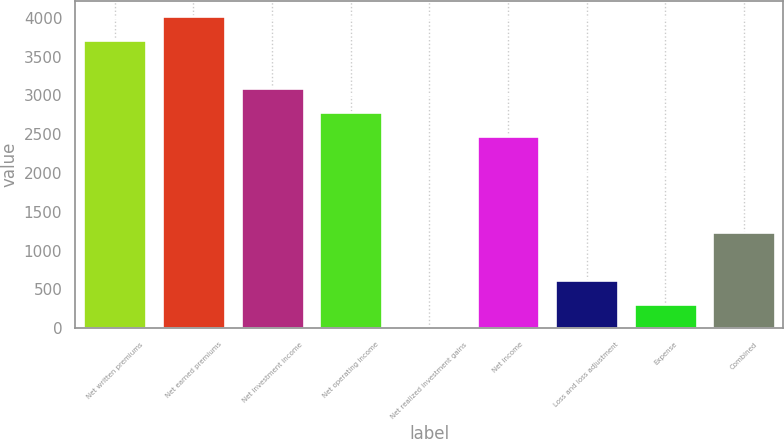<chart> <loc_0><loc_0><loc_500><loc_500><bar_chart><fcel>Net written premiums<fcel>Net earned premiums<fcel>Net investment income<fcel>Net operating income<fcel>Net realized investment gains<fcel>Net income<fcel>Loss and loss adjustment<fcel>Expense<fcel>Combined<nl><fcel>3709<fcel>4018<fcel>3091<fcel>2782<fcel>1<fcel>2473<fcel>619<fcel>310<fcel>1237<nl></chart> 